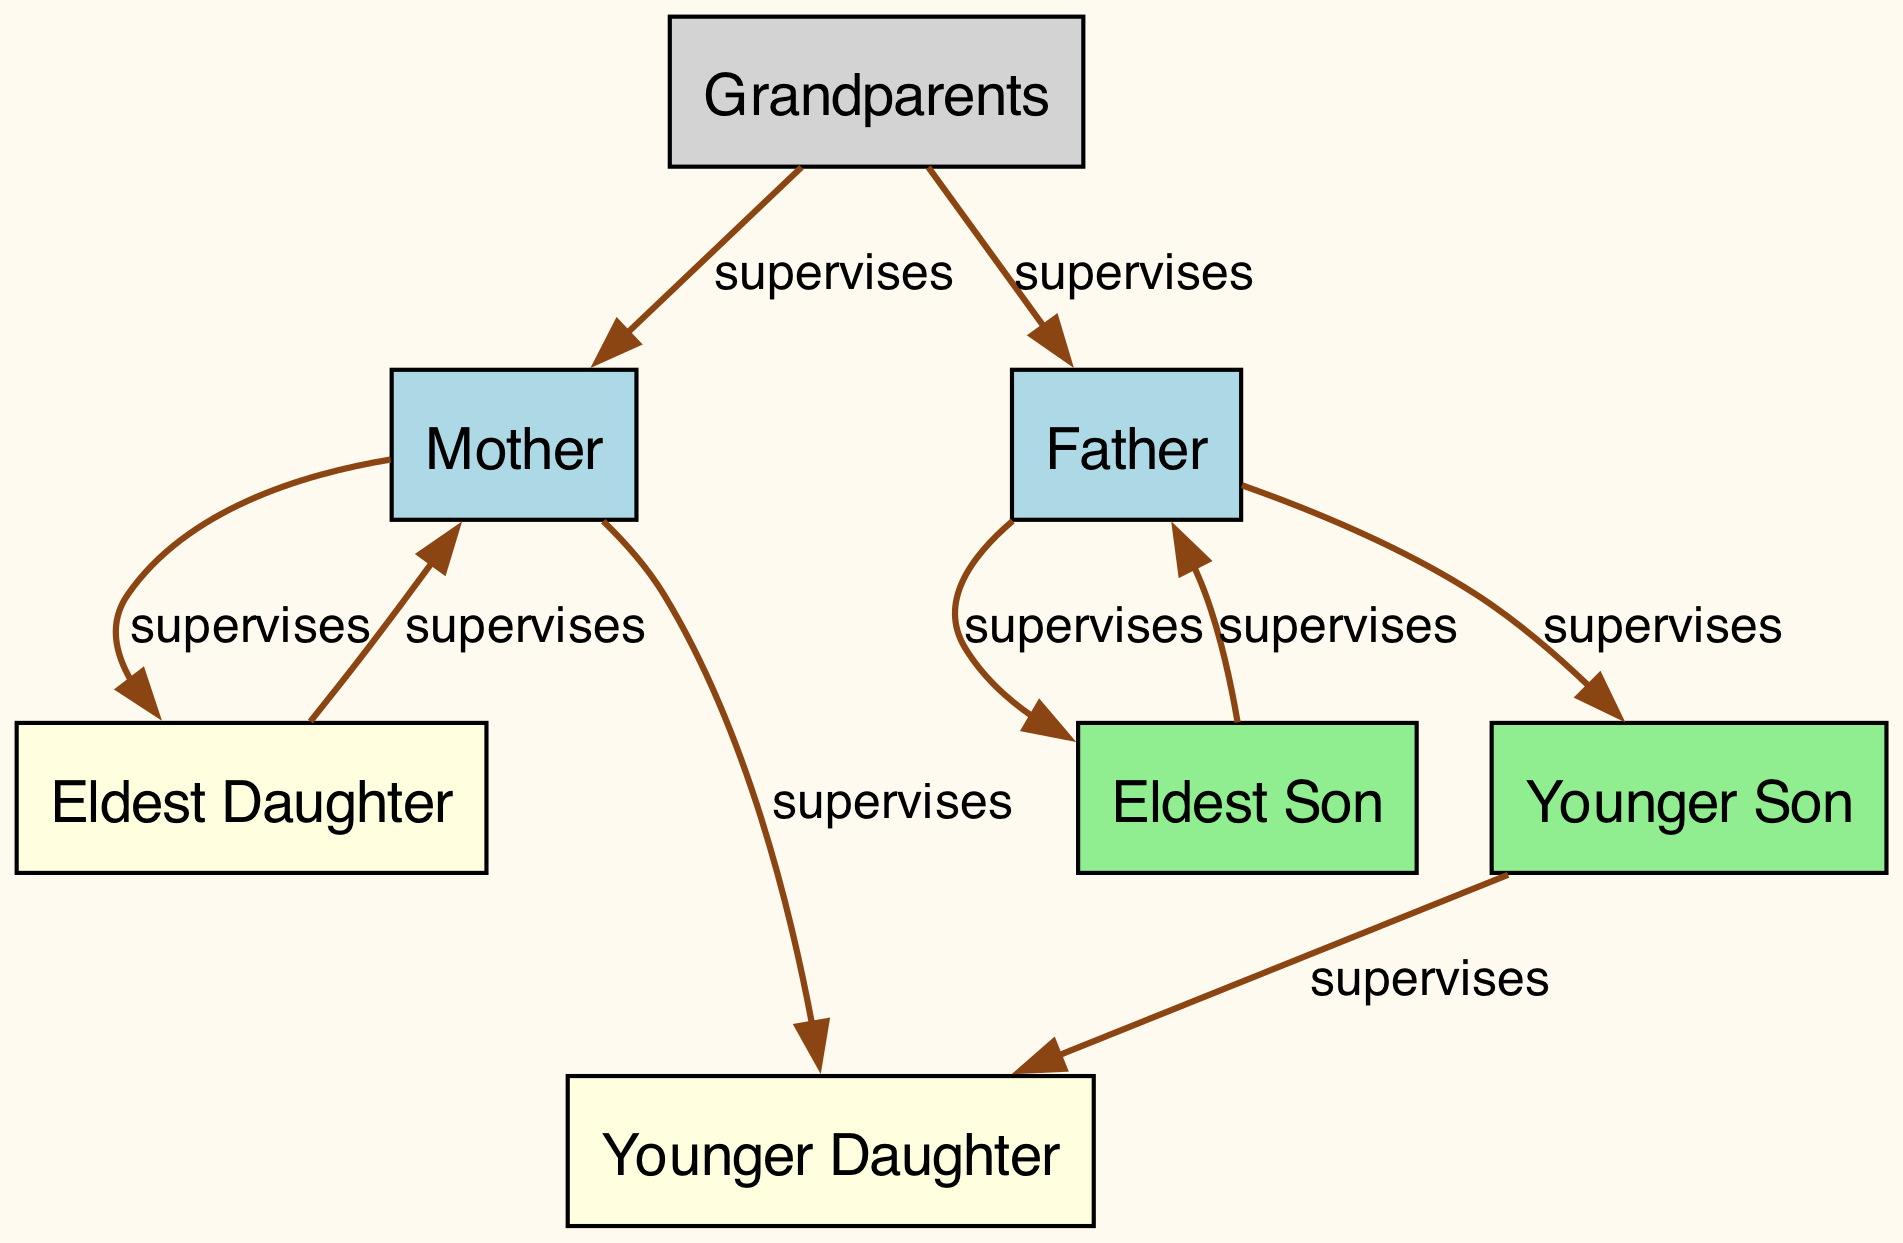What family member supervises the Younger Daughter? The Younger Daughter is connected by an edge from the Mother, indicating that the Mother supervises her.
Answer: Mother How many family members are supervising tasks in the graph? There are five nodes (family members) with outgoing edges that supervise others: the Mother, Father, Eldest Son, Eldest Daughter, and Grandparents. Each has at least one supervising connection.
Answer: Five Who supervises the Eldest Son? The Eldest Son has an edge leading to the Father, showing that the Father supervises him.
Answer: Father Which family member is supervised by both parents? The Eldest Daughter has edges leading from both the Mother and Grandparents, meaning she is supervised by both.
Answer: Eldest Daughter How many nodes are there in total? By counting the unique family members listed in the nodes section, there are seven nodes in total: Mother, Father, Eldest Son, Eldest Daughter, Younger Son, Younger Daughter, and Grandparents.
Answer: Seven Who supervises the Younger Son? The Younger Son is supervised exclusively by the Father, as indicated by the directed edge between them.
Answer: Father Which family member has the most supervision connections? The Mother has two outbound edges: one to the Eldest Daughter and another to the Younger Daughter, indicating she supervises two family members.
Answer: Mother Which family member supervises the Younger Daughter? The diagram shows that the Mother supervises the Younger Daughter by the directed edge pointing from Mother to Younger Daughter.
Answer: Mother How many edges are pointing out from the Grandparents? The Grandparents supervise two family members (Mother and Father), so there are two edges pointing outward from them.
Answer: Two 